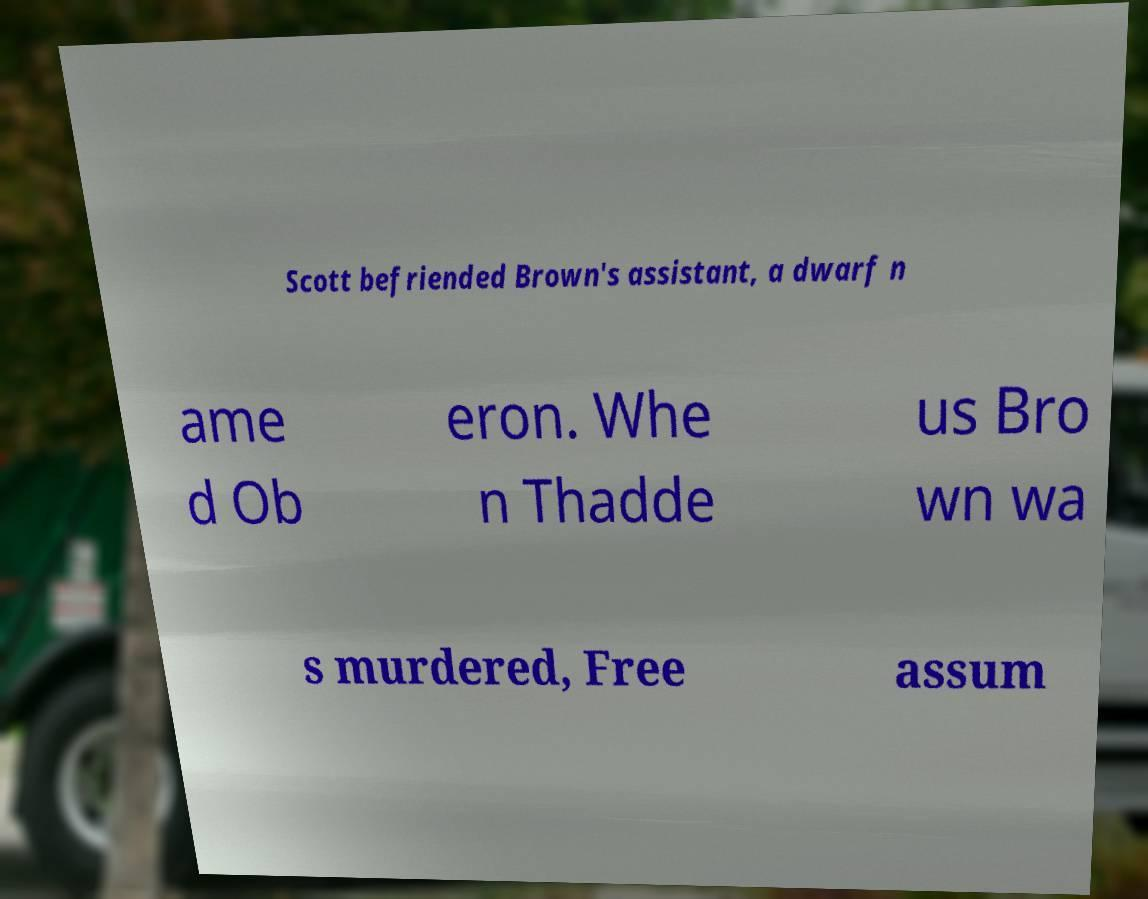Could you extract and type out the text from this image? Scott befriended Brown's assistant, a dwarf n ame d Ob eron. Whe n Thadde us Bro wn wa s murdered, Free assum 